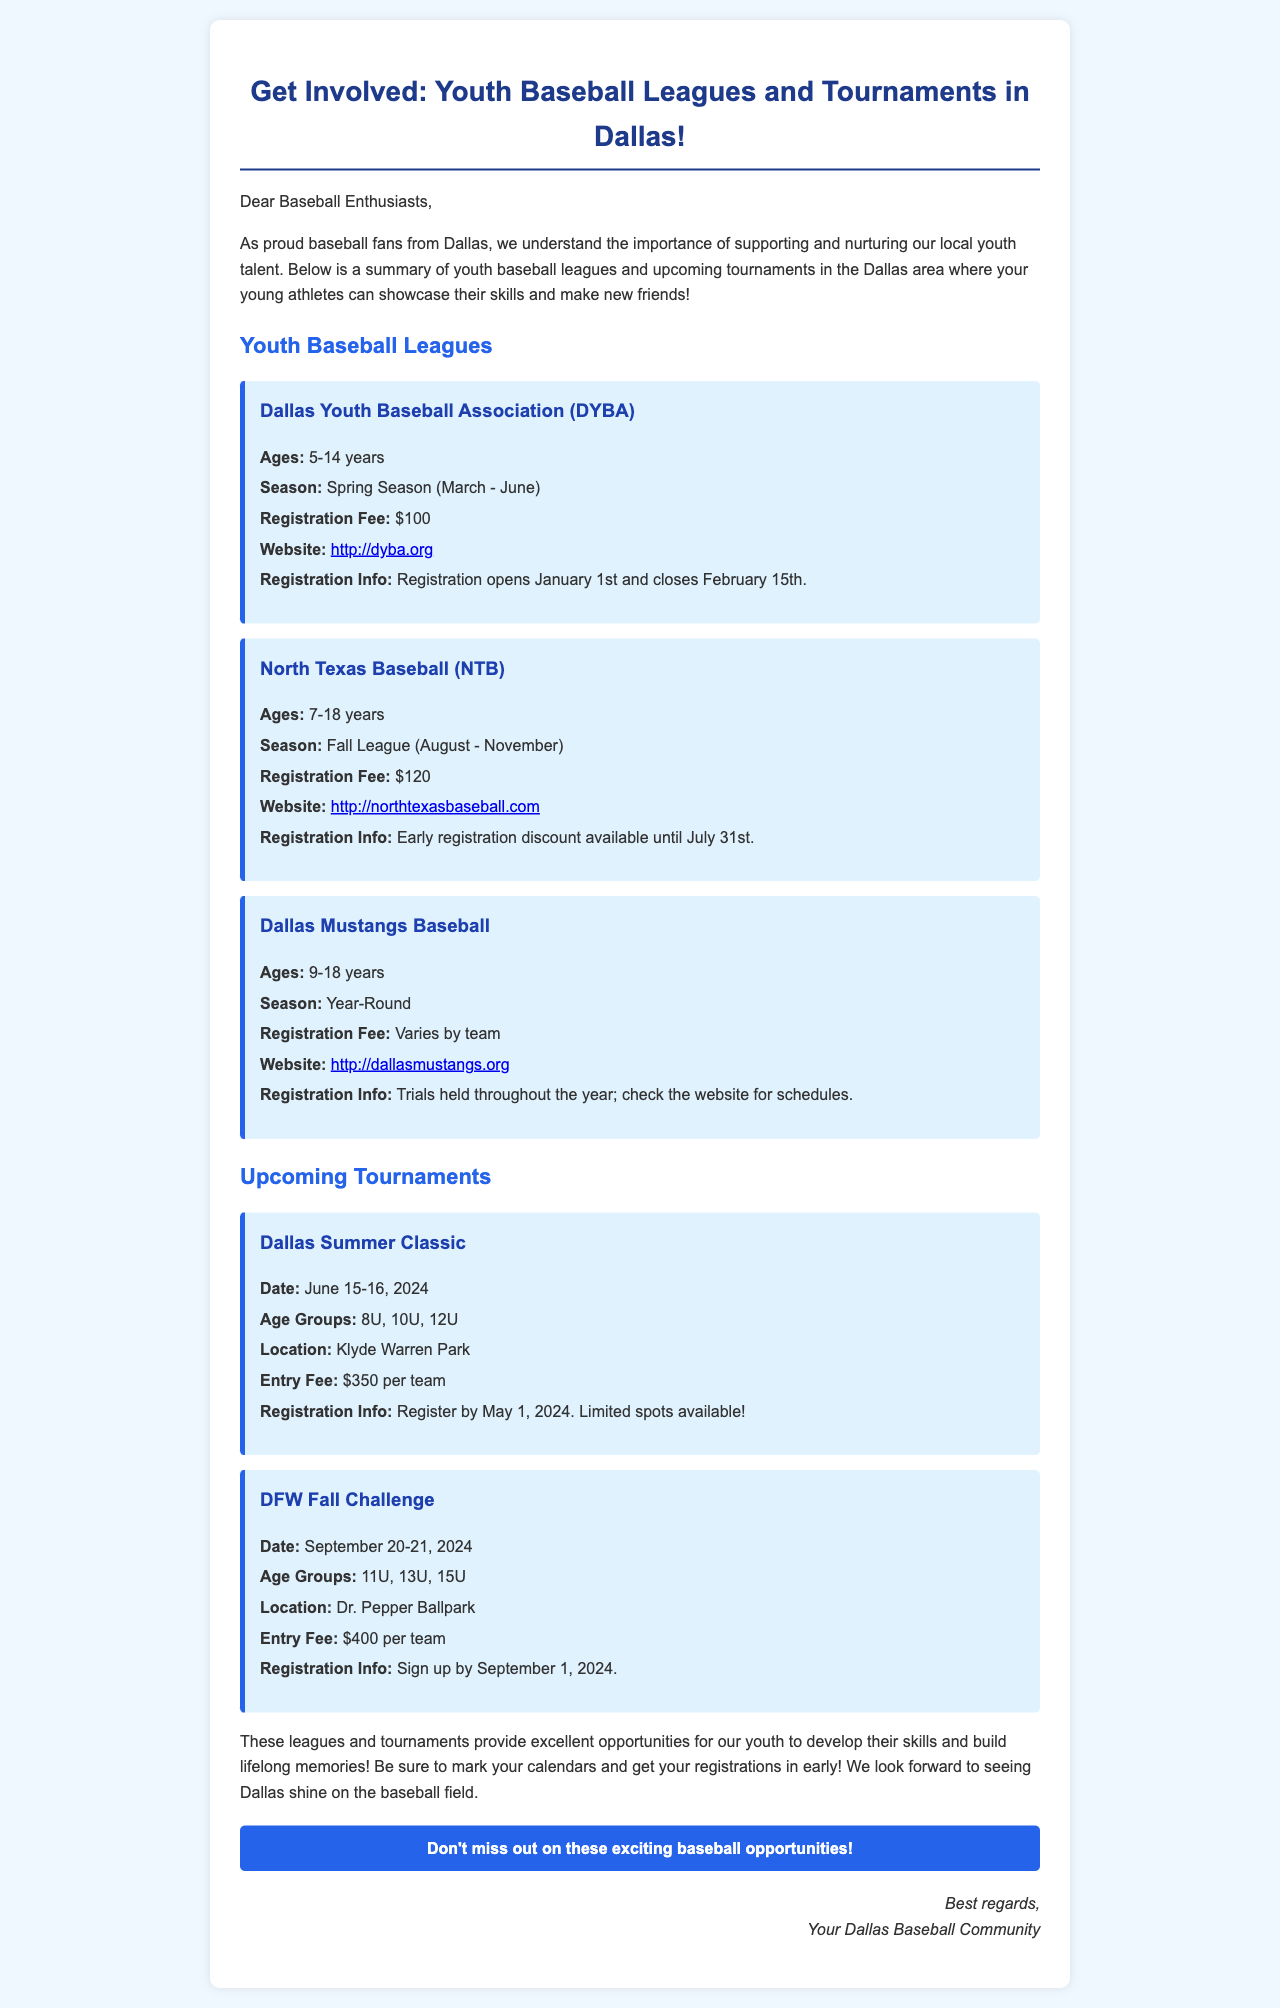What are the ages for Dallas Youth Baseball Association? The ages for the Dallas Youth Baseball Association are specified as 5-14 years in the document.
Answer: 5-14 years What is the registration fee for North Texas Baseball? The document states that the registration fee for North Texas Baseball is $120.
Answer: $120 When does registration open for the Dallas Youth Baseball Association? The document mentions that registration opens on January 1st.
Answer: January 1st What is the date for the Dallas Summer Classic tournament? The document lists the date for the Dallas Summer Classic as June 15-16, 2024.
Answer: June 15-16, 2024 Which age groups are included in the DFW Fall Challenge? The document indicates that the age groups for the DFW Fall Challenge are 11U, 13U, 15U.
Answer: 11U, 13U, 15U Why is early registration discounted for North Texas Baseball? The document states that early registration discount is available until July 31st, implying an incentive to register early.
Answer: Incentive to register early What is the entry fee for the Dallas Summer Classic? The document specifies that the entry fee for the Dallas Summer Classic is $350 per team.
Answer: $350 per team What seasonal timing does the Dallas Youth Baseball Association operate? The document indicates that the Dallas Youth Baseball Association operates during the Spring Season, which runs from March to June.
Answer: Spring Season (March - June) 